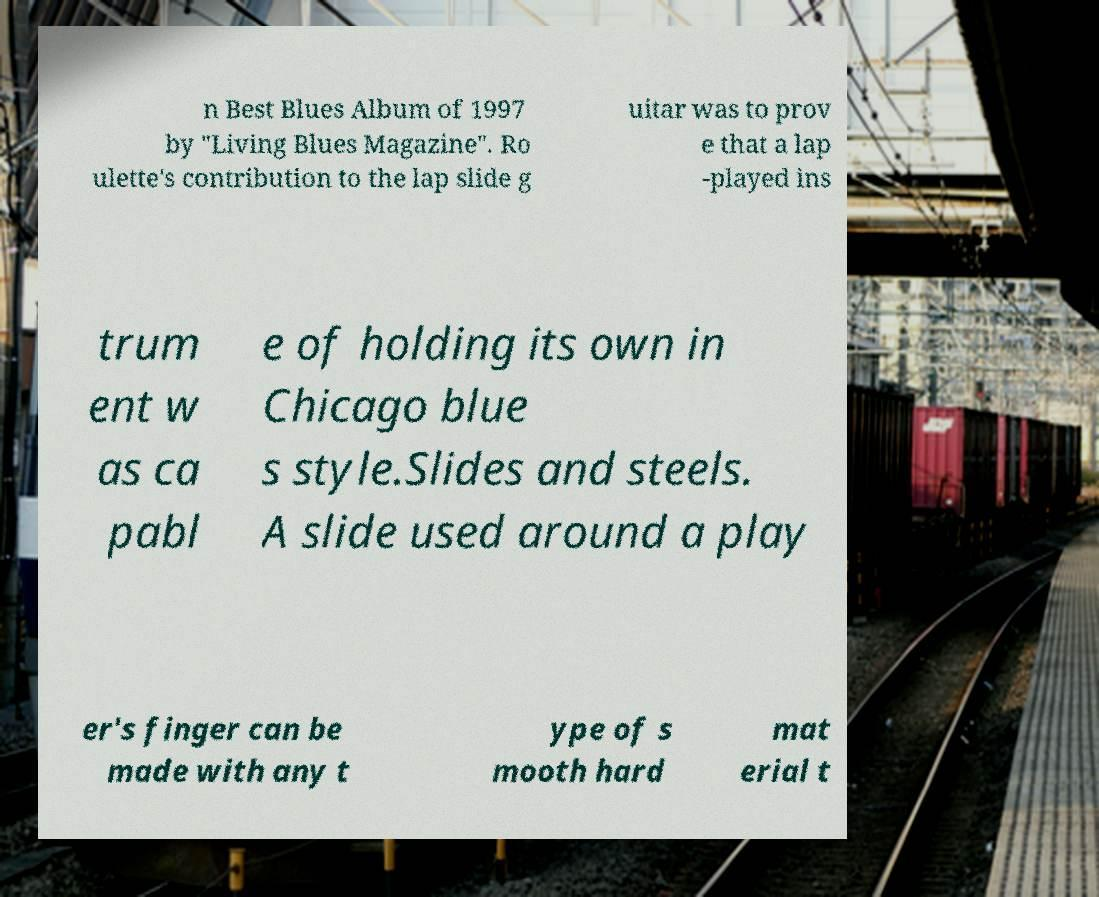For documentation purposes, I need the text within this image transcribed. Could you provide that? n Best Blues Album of 1997 by "Living Blues Magazine". Ro ulette's contribution to the lap slide g uitar was to prov e that a lap -played ins trum ent w as ca pabl e of holding its own in Chicago blue s style.Slides and steels. A slide used around a play er's finger can be made with any t ype of s mooth hard mat erial t 